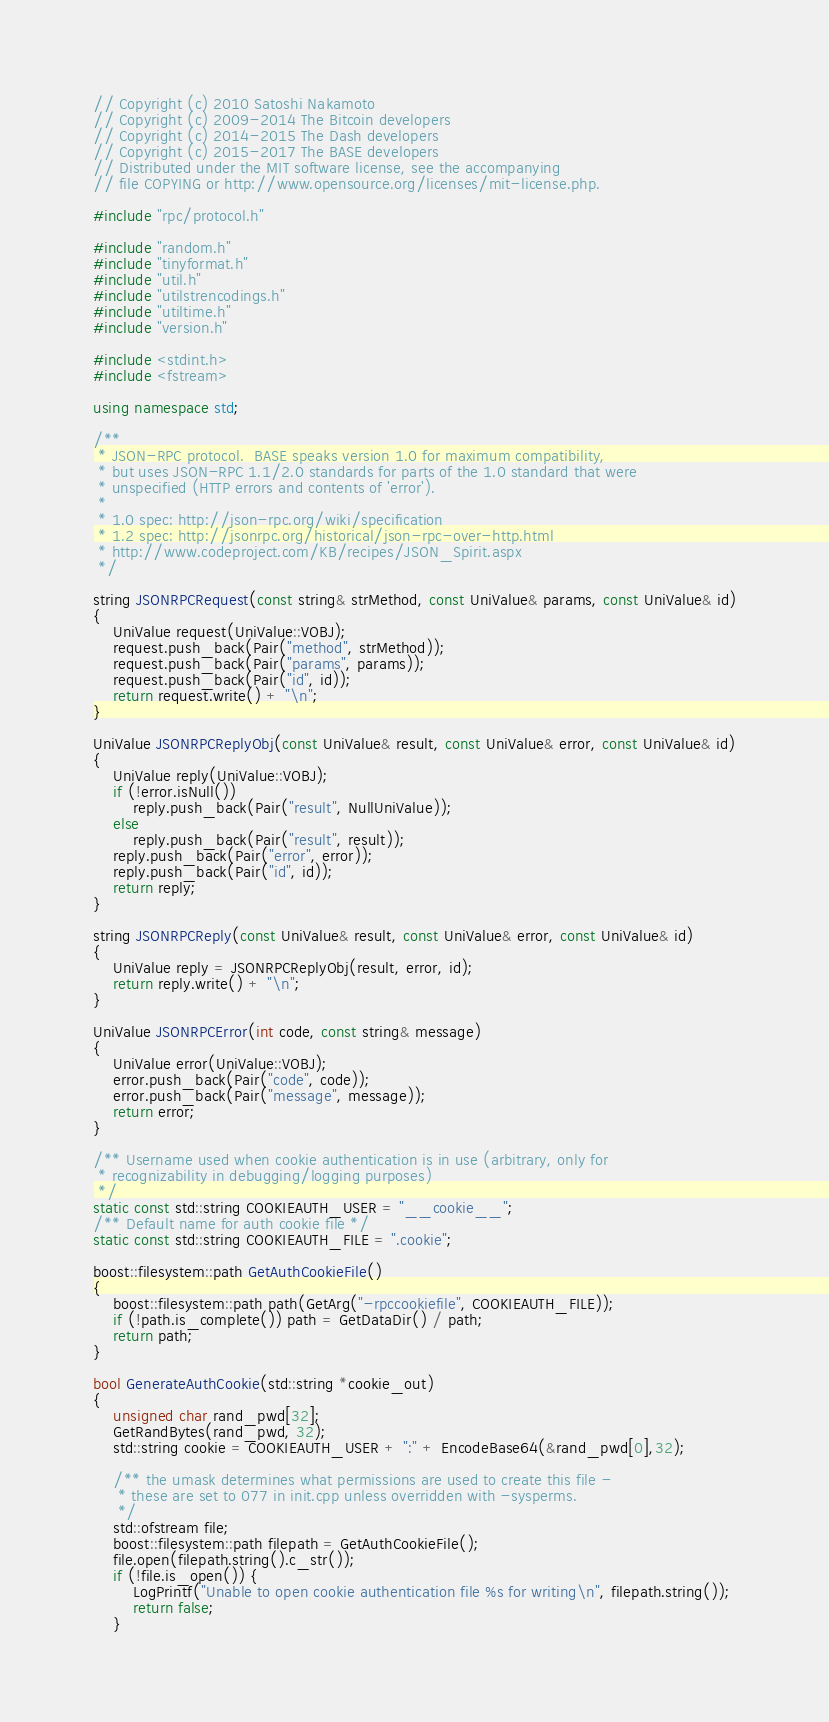<code> <loc_0><loc_0><loc_500><loc_500><_C++_>// Copyright (c) 2010 Satoshi Nakamoto
// Copyright (c) 2009-2014 The Bitcoin developers
// Copyright (c) 2014-2015 The Dash developers
// Copyright (c) 2015-2017 The BASE developers
// Distributed under the MIT software license, see the accompanying
// file COPYING or http://www.opensource.org/licenses/mit-license.php.

#include "rpc/protocol.h"

#include "random.h"
#include "tinyformat.h"
#include "util.h"
#include "utilstrencodings.h"
#include "utiltime.h"
#include "version.h"

#include <stdint.h>
#include <fstream>

using namespace std;

/**
 * JSON-RPC protocol.  BASE speaks version 1.0 for maximum compatibility,
 * but uses JSON-RPC 1.1/2.0 standards for parts of the 1.0 standard that were
 * unspecified (HTTP errors and contents of 'error').
 *
 * 1.0 spec: http://json-rpc.org/wiki/specification
 * 1.2 spec: http://jsonrpc.org/historical/json-rpc-over-http.html
 * http://www.codeproject.com/KB/recipes/JSON_Spirit.aspx
 */

string JSONRPCRequest(const string& strMethod, const UniValue& params, const UniValue& id)
{
    UniValue request(UniValue::VOBJ);
    request.push_back(Pair("method", strMethod));
    request.push_back(Pair("params", params));
    request.push_back(Pair("id", id));
    return request.write() + "\n";
}

UniValue JSONRPCReplyObj(const UniValue& result, const UniValue& error, const UniValue& id)
{
    UniValue reply(UniValue::VOBJ);
    if (!error.isNull())
        reply.push_back(Pair("result", NullUniValue));
    else
        reply.push_back(Pair("result", result));
    reply.push_back(Pair("error", error));
    reply.push_back(Pair("id", id));
    return reply;
}

string JSONRPCReply(const UniValue& result, const UniValue& error, const UniValue& id)
{
    UniValue reply = JSONRPCReplyObj(result, error, id);
    return reply.write() + "\n";
}

UniValue JSONRPCError(int code, const string& message)
{
    UniValue error(UniValue::VOBJ);
    error.push_back(Pair("code", code));
    error.push_back(Pair("message", message));
    return error;
}

/** Username used when cookie authentication is in use (arbitrary, only for
 * recognizability in debugging/logging purposes)
 */
static const std::string COOKIEAUTH_USER = "__cookie__";
/** Default name for auth cookie file */
static const std::string COOKIEAUTH_FILE = ".cookie";

boost::filesystem::path GetAuthCookieFile()
{
    boost::filesystem::path path(GetArg("-rpccookiefile", COOKIEAUTH_FILE));
    if (!path.is_complete()) path = GetDataDir() / path;
    return path;
}

bool GenerateAuthCookie(std::string *cookie_out)
{
    unsigned char rand_pwd[32];
    GetRandBytes(rand_pwd, 32);
    std::string cookie = COOKIEAUTH_USER + ":" + EncodeBase64(&rand_pwd[0],32);

    /** the umask determines what permissions are used to create this file -
     * these are set to 077 in init.cpp unless overridden with -sysperms.
     */
    std::ofstream file;
    boost::filesystem::path filepath = GetAuthCookieFile();
    file.open(filepath.string().c_str());
    if (!file.is_open()) {
        LogPrintf("Unable to open cookie authentication file %s for writing\n", filepath.string());
        return false;
    }</code> 